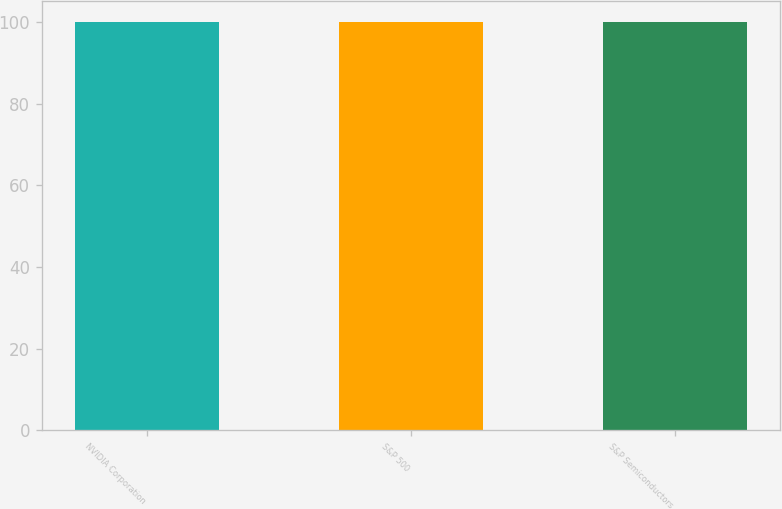Convert chart. <chart><loc_0><loc_0><loc_500><loc_500><bar_chart><fcel>NVIDIA Corporation<fcel>S&P 500<fcel>S&P Semiconductors<nl><fcel>100<fcel>100.1<fcel>100.2<nl></chart> 